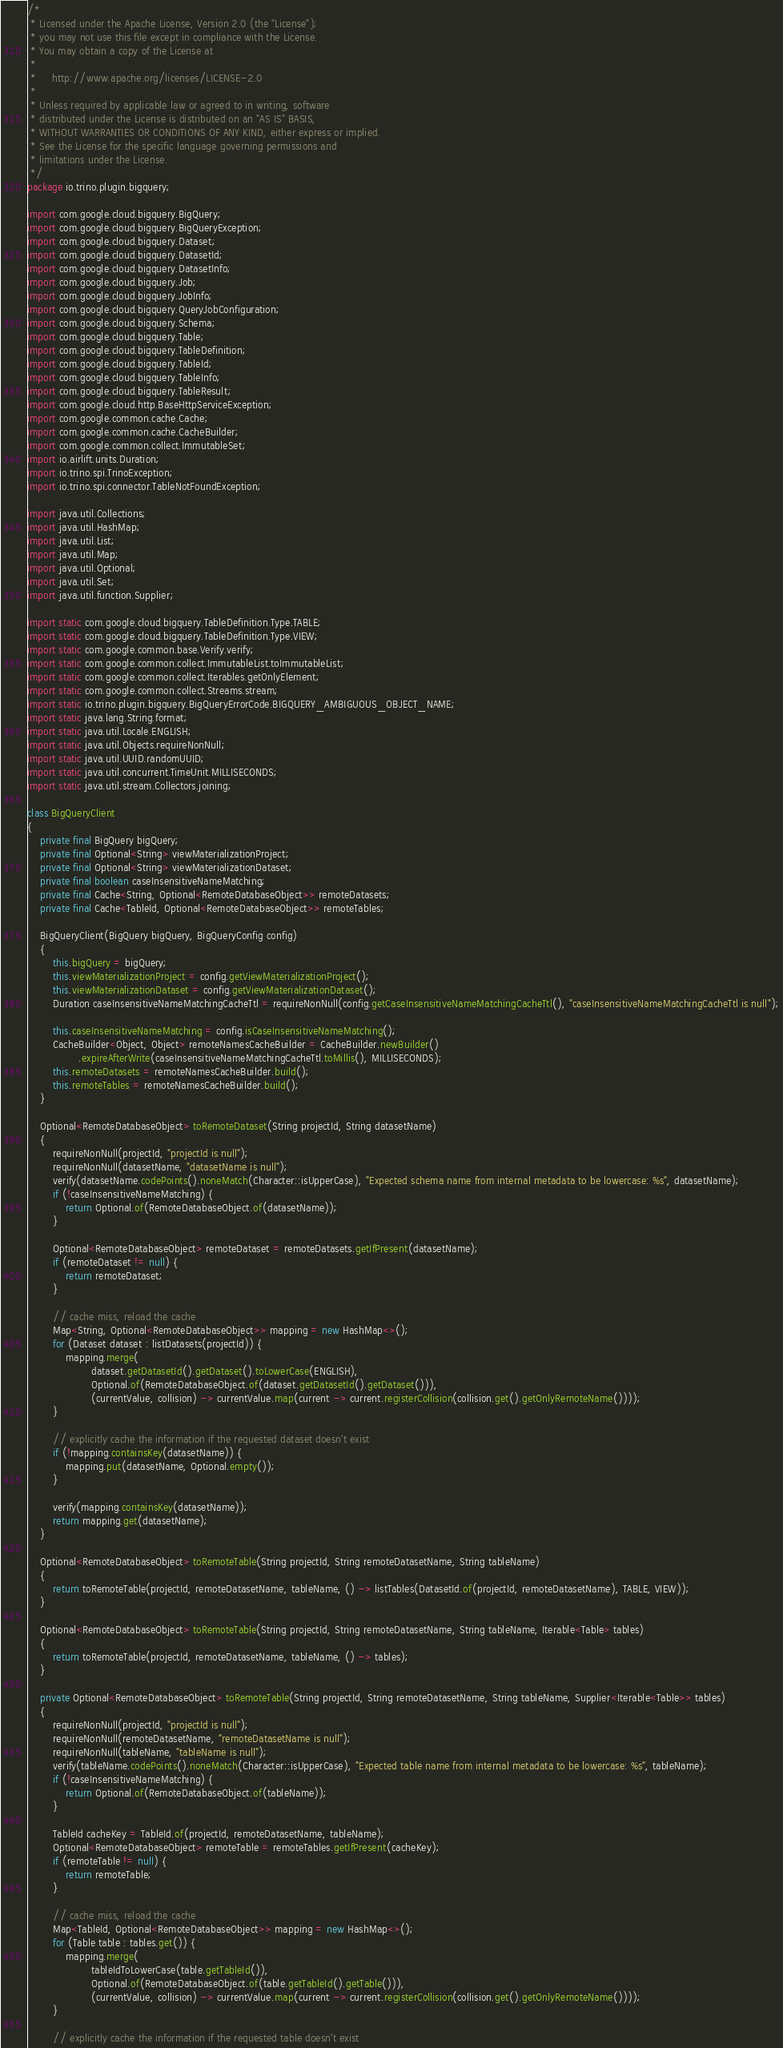Convert code to text. <code><loc_0><loc_0><loc_500><loc_500><_Java_>/*
 * Licensed under the Apache License, Version 2.0 (the "License");
 * you may not use this file except in compliance with the License.
 * You may obtain a copy of the License at
 *
 *     http://www.apache.org/licenses/LICENSE-2.0
 *
 * Unless required by applicable law or agreed to in writing, software
 * distributed under the License is distributed on an "AS IS" BASIS,
 * WITHOUT WARRANTIES OR CONDITIONS OF ANY KIND, either express or implied.
 * See the License for the specific language governing permissions and
 * limitations under the License.
 */
package io.trino.plugin.bigquery;

import com.google.cloud.bigquery.BigQuery;
import com.google.cloud.bigquery.BigQueryException;
import com.google.cloud.bigquery.Dataset;
import com.google.cloud.bigquery.DatasetId;
import com.google.cloud.bigquery.DatasetInfo;
import com.google.cloud.bigquery.Job;
import com.google.cloud.bigquery.JobInfo;
import com.google.cloud.bigquery.QueryJobConfiguration;
import com.google.cloud.bigquery.Schema;
import com.google.cloud.bigquery.Table;
import com.google.cloud.bigquery.TableDefinition;
import com.google.cloud.bigquery.TableId;
import com.google.cloud.bigquery.TableInfo;
import com.google.cloud.bigquery.TableResult;
import com.google.cloud.http.BaseHttpServiceException;
import com.google.common.cache.Cache;
import com.google.common.cache.CacheBuilder;
import com.google.common.collect.ImmutableSet;
import io.airlift.units.Duration;
import io.trino.spi.TrinoException;
import io.trino.spi.connector.TableNotFoundException;

import java.util.Collections;
import java.util.HashMap;
import java.util.List;
import java.util.Map;
import java.util.Optional;
import java.util.Set;
import java.util.function.Supplier;

import static com.google.cloud.bigquery.TableDefinition.Type.TABLE;
import static com.google.cloud.bigquery.TableDefinition.Type.VIEW;
import static com.google.common.base.Verify.verify;
import static com.google.common.collect.ImmutableList.toImmutableList;
import static com.google.common.collect.Iterables.getOnlyElement;
import static com.google.common.collect.Streams.stream;
import static io.trino.plugin.bigquery.BigQueryErrorCode.BIGQUERY_AMBIGUOUS_OBJECT_NAME;
import static java.lang.String.format;
import static java.util.Locale.ENGLISH;
import static java.util.Objects.requireNonNull;
import static java.util.UUID.randomUUID;
import static java.util.concurrent.TimeUnit.MILLISECONDS;
import static java.util.stream.Collectors.joining;

class BigQueryClient
{
    private final BigQuery bigQuery;
    private final Optional<String> viewMaterializationProject;
    private final Optional<String> viewMaterializationDataset;
    private final boolean caseInsensitiveNameMatching;
    private final Cache<String, Optional<RemoteDatabaseObject>> remoteDatasets;
    private final Cache<TableId, Optional<RemoteDatabaseObject>> remoteTables;

    BigQueryClient(BigQuery bigQuery, BigQueryConfig config)
    {
        this.bigQuery = bigQuery;
        this.viewMaterializationProject = config.getViewMaterializationProject();
        this.viewMaterializationDataset = config.getViewMaterializationDataset();
        Duration caseInsensitiveNameMatchingCacheTtl = requireNonNull(config.getCaseInsensitiveNameMatchingCacheTtl(), "caseInsensitiveNameMatchingCacheTtl is null");

        this.caseInsensitiveNameMatching = config.isCaseInsensitiveNameMatching();
        CacheBuilder<Object, Object> remoteNamesCacheBuilder = CacheBuilder.newBuilder()
                .expireAfterWrite(caseInsensitiveNameMatchingCacheTtl.toMillis(), MILLISECONDS);
        this.remoteDatasets = remoteNamesCacheBuilder.build();
        this.remoteTables = remoteNamesCacheBuilder.build();
    }

    Optional<RemoteDatabaseObject> toRemoteDataset(String projectId, String datasetName)
    {
        requireNonNull(projectId, "projectId is null");
        requireNonNull(datasetName, "datasetName is null");
        verify(datasetName.codePoints().noneMatch(Character::isUpperCase), "Expected schema name from internal metadata to be lowercase: %s", datasetName);
        if (!caseInsensitiveNameMatching) {
            return Optional.of(RemoteDatabaseObject.of(datasetName));
        }

        Optional<RemoteDatabaseObject> remoteDataset = remoteDatasets.getIfPresent(datasetName);
        if (remoteDataset != null) {
            return remoteDataset;
        }

        // cache miss, reload the cache
        Map<String, Optional<RemoteDatabaseObject>> mapping = new HashMap<>();
        for (Dataset dataset : listDatasets(projectId)) {
            mapping.merge(
                    dataset.getDatasetId().getDataset().toLowerCase(ENGLISH),
                    Optional.of(RemoteDatabaseObject.of(dataset.getDatasetId().getDataset())),
                    (currentValue, collision) -> currentValue.map(current -> current.registerCollision(collision.get().getOnlyRemoteName())));
        }

        // explicitly cache the information if the requested dataset doesn't exist
        if (!mapping.containsKey(datasetName)) {
            mapping.put(datasetName, Optional.empty());
        }

        verify(mapping.containsKey(datasetName));
        return mapping.get(datasetName);
    }

    Optional<RemoteDatabaseObject> toRemoteTable(String projectId, String remoteDatasetName, String tableName)
    {
        return toRemoteTable(projectId, remoteDatasetName, tableName, () -> listTables(DatasetId.of(projectId, remoteDatasetName), TABLE, VIEW));
    }

    Optional<RemoteDatabaseObject> toRemoteTable(String projectId, String remoteDatasetName, String tableName, Iterable<Table> tables)
    {
        return toRemoteTable(projectId, remoteDatasetName, tableName, () -> tables);
    }

    private Optional<RemoteDatabaseObject> toRemoteTable(String projectId, String remoteDatasetName, String tableName, Supplier<Iterable<Table>> tables)
    {
        requireNonNull(projectId, "projectId is null");
        requireNonNull(remoteDatasetName, "remoteDatasetName is null");
        requireNonNull(tableName, "tableName is null");
        verify(tableName.codePoints().noneMatch(Character::isUpperCase), "Expected table name from internal metadata to be lowercase: %s", tableName);
        if (!caseInsensitiveNameMatching) {
            return Optional.of(RemoteDatabaseObject.of(tableName));
        }

        TableId cacheKey = TableId.of(projectId, remoteDatasetName, tableName);
        Optional<RemoteDatabaseObject> remoteTable = remoteTables.getIfPresent(cacheKey);
        if (remoteTable != null) {
            return remoteTable;
        }

        // cache miss, reload the cache
        Map<TableId, Optional<RemoteDatabaseObject>> mapping = new HashMap<>();
        for (Table table : tables.get()) {
            mapping.merge(
                    tableIdToLowerCase(table.getTableId()),
                    Optional.of(RemoteDatabaseObject.of(table.getTableId().getTable())),
                    (currentValue, collision) -> currentValue.map(current -> current.registerCollision(collision.get().getOnlyRemoteName())));
        }

        // explicitly cache the information if the requested table doesn't exist</code> 